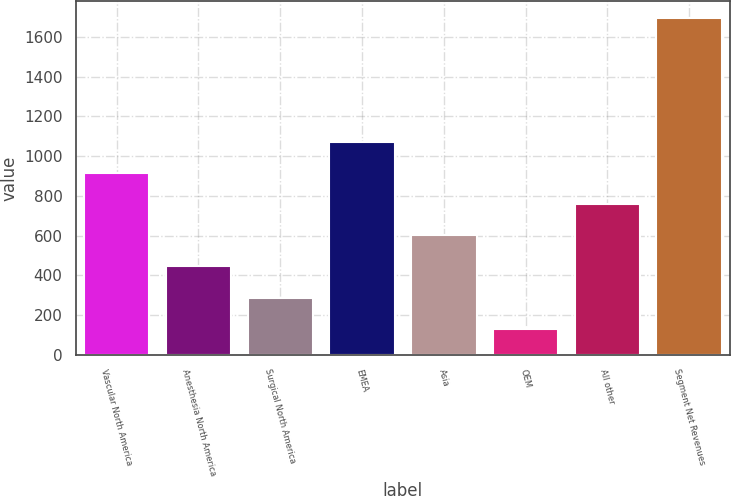Convert chart. <chart><loc_0><loc_0><loc_500><loc_500><bar_chart><fcel>Vascular North America<fcel>Anesthesia North America<fcel>Surgical North America<fcel>EMEA<fcel>Asia<fcel>OEM<fcel>All other<fcel>Segment Net Revenues<nl><fcel>913.75<fcel>444.22<fcel>287.71<fcel>1070.26<fcel>600.73<fcel>131.2<fcel>757.24<fcel>1696.3<nl></chart> 